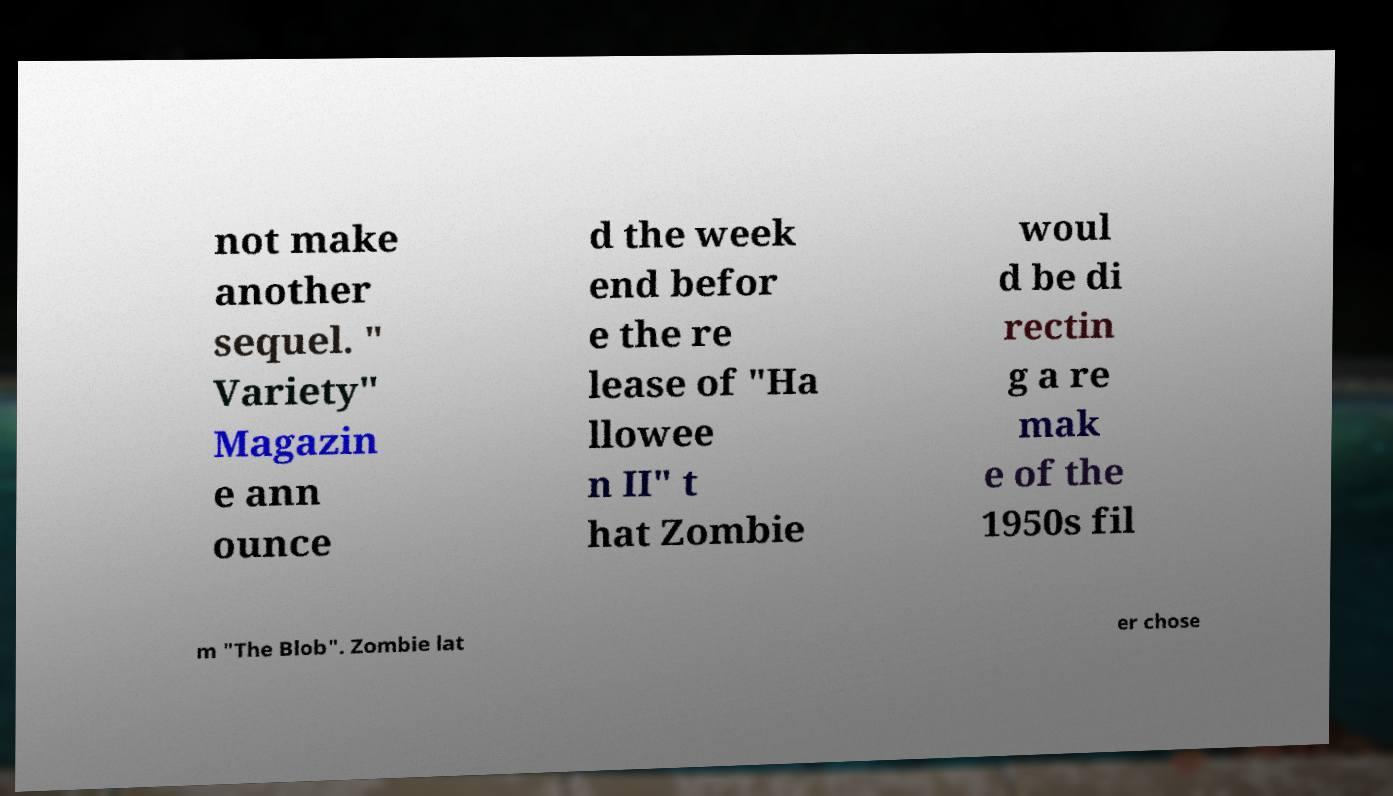Please identify and transcribe the text found in this image. not make another sequel. " Variety" Magazin e ann ounce d the week end befor e the re lease of "Ha llowee n II" t hat Zombie woul d be di rectin g a re mak e of the 1950s fil m "The Blob". Zombie lat er chose 